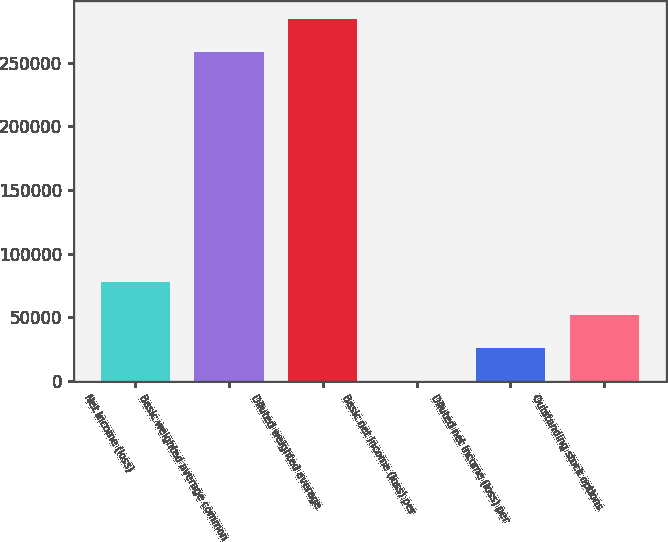Convert chart to OTSL. <chart><loc_0><loc_0><loc_500><loc_500><bar_chart><fcel>Net income (loss)<fcel>Basic weighted average common<fcel>Diluted weighted average<fcel>Basic net income (loss) per<fcel>Diluted net income (loss) per<fcel>Outstanding stock options<nl><fcel>77623.1<fcel>258743<fcel>284617<fcel>0.24<fcel>25874.5<fcel>51748.8<nl></chart> 